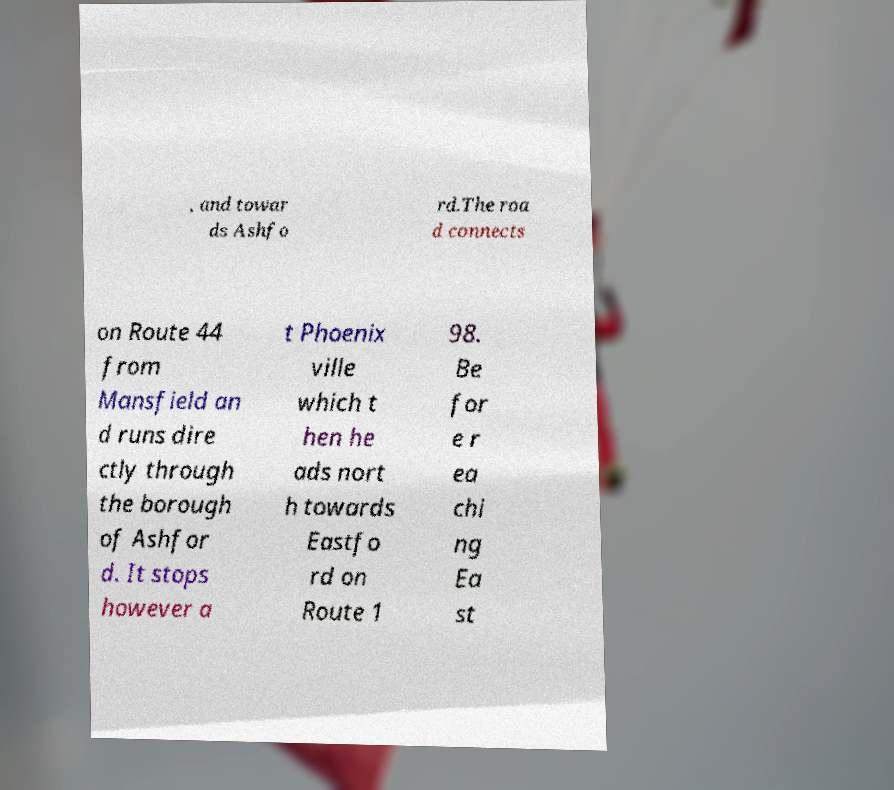I need the written content from this picture converted into text. Can you do that? , and towar ds Ashfo rd.The roa d connects on Route 44 from Mansfield an d runs dire ctly through the borough of Ashfor d. It stops however a t Phoenix ville which t hen he ads nort h towards Eastfo rd on Route 1 98. Be for e r ea chi ng Ea st 